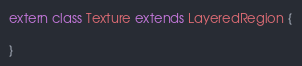Convert code to text. <code><loc_0><loc_0><loc_500><loc_500><_Haxe_>extern class Texture extends LayeredRegion {

}
</code> 